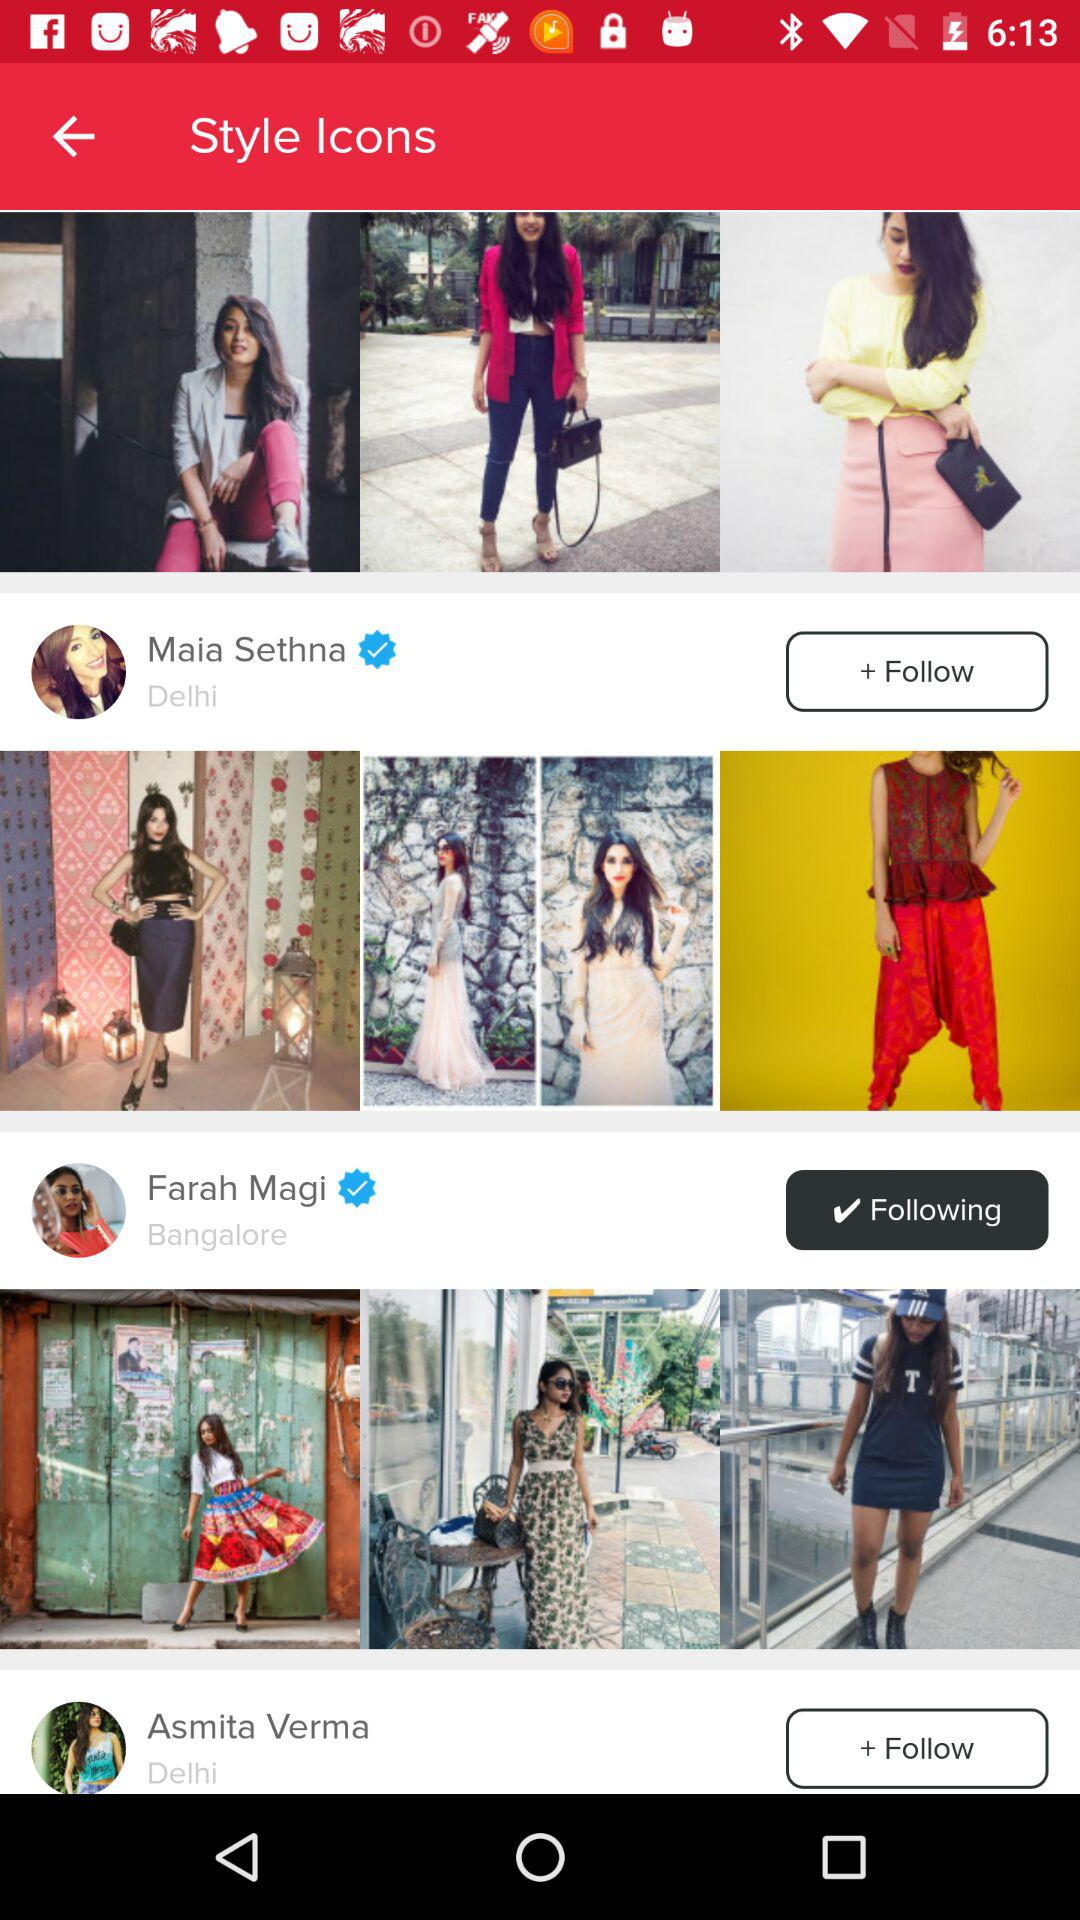What is the location of Asmita Verma? The location is Delhi. 